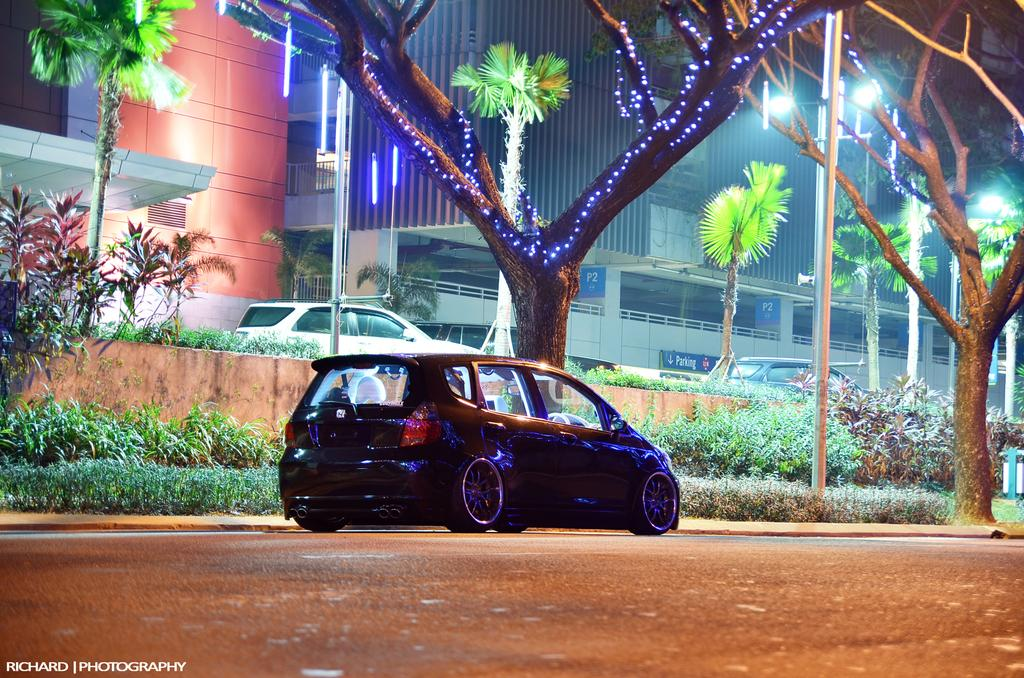What is the main subject of the image? There is a car on the road in the image. What type of natural elements can be seen in the image? There are plants and trees visible in the image. Can you describe the decorative element on the tree? There is a rope light on a tree in the image. What can be seen in the distance in the image? There are buildings and cars in the background of the image. What type of dirt is being discussed in the image? There is no discussion about dirt in the image. What type of cable can be seen connecting the car to the tree? There is no cable connecting the car to the tree in the image. 